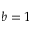Convert formula to latex. <formula><loc_0><loc_0><loc_500><loc_500>b = 1</formula> 